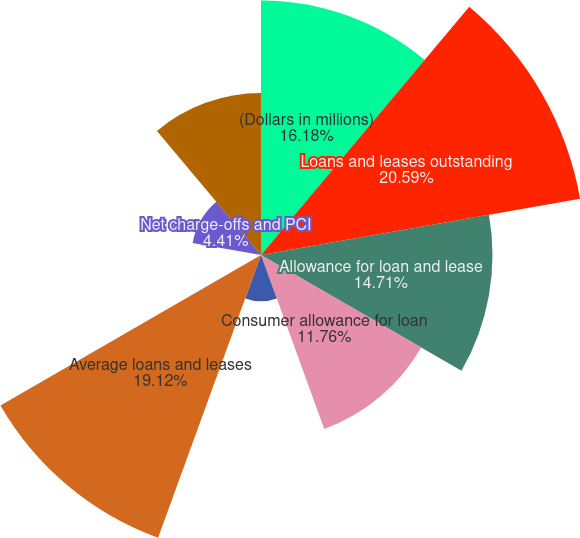<chart> <loc_0><loc_0><loc_500><loc_500><pie_chart><fcel>(Dollars in millions)<fcel>Loans and leases outstanding<fcel>Allowance for loan and lease<fcel>Consumer allowance for loan<fcel>Commercial allowance for loan<fcel>Average loans and leases<fcel>Net charge-offs as a<fcel>Net charge-offs and PCI<fcel>Ratio of the allowance for<nl><fcel>16.18%<fcel>20.59%<fcel>14.71%<fcel>11.76%<fcel>2.94%<fcel>19.12%<fcel>0.0%<fcel>4.41%<fcel>10.29%<nl></chart> 